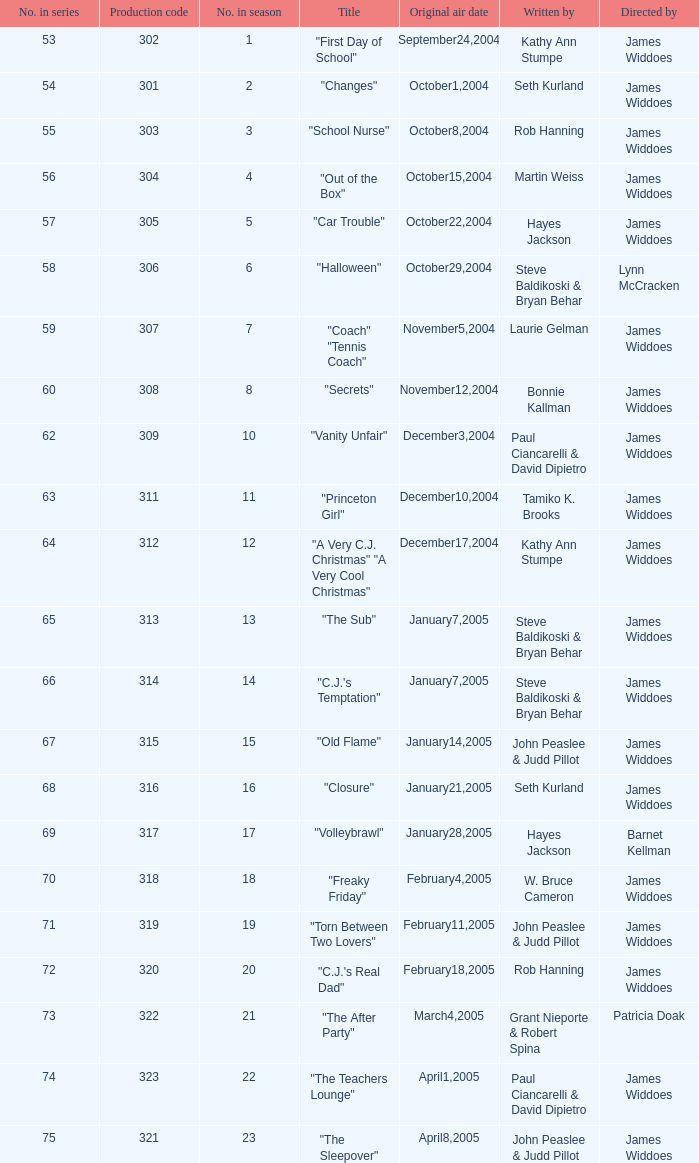What date was the episode originally aired that was directed by James Widdoes and the production code is 320? February18,2005. 